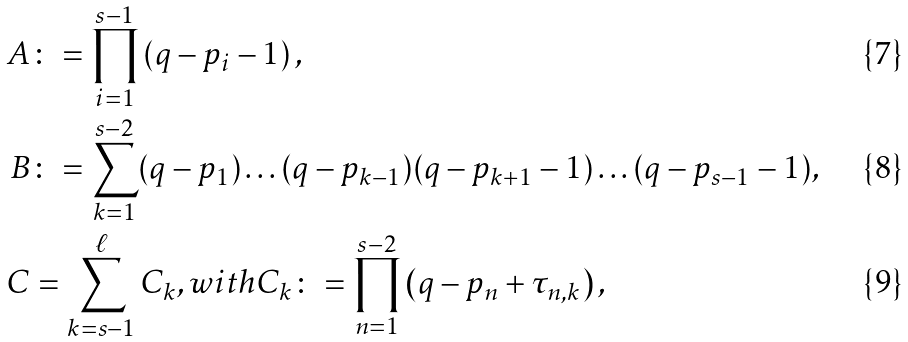Convert formula to latex. <formula><loc_0><loc_0><loc_500><loc_500>A & \colon = \prod _ { i = 1 } ^ { s - 1 } \left ( q - p _ { i } - 1 \right ) , \\ B & \colon = \sum _ { k = 1 } ^ { s - 2 } ( q - p _ { 1 } ) \dots ( q - p _ { k - 1 } ) ( q - p _ { k + 1 } - 1 ) \dots ( q - p _ { s - 1 } - 1 ) , \\ C & = \sum _ { k = s - 1 } ^ { \ell } C _ { k } , w i t h C _ { k } \colon = \prod _ { n = 1 } ^ { s - 2 } \left ( q - p _ { n } + \tau _ { n , k } \right ) ,</formula> 